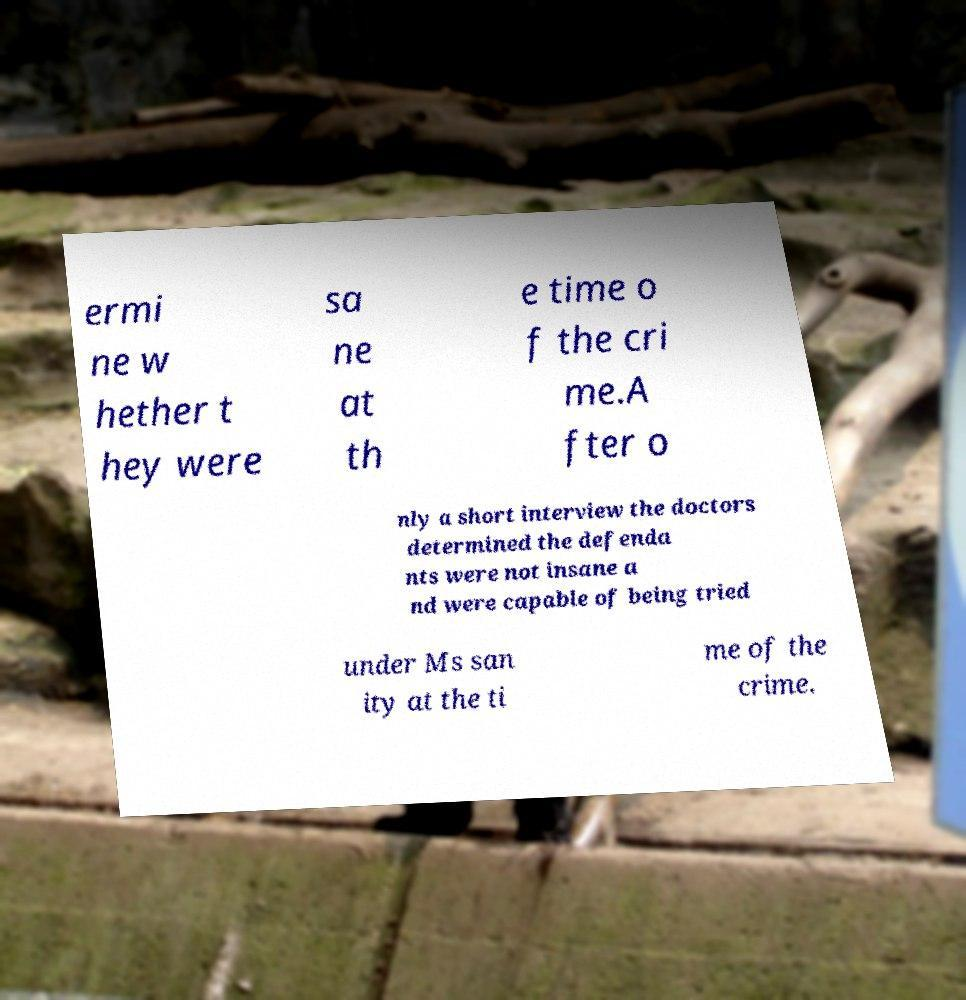I need the written content from this picture converted into text. Can you do that? ermi ne w hether t hey were sa ne at th e time o f the cri me.A fter o nly a short interview the doctors determined the defenda nts were not insane a nd were capable of being tried under Ms san ity at the ti me of the crime. 